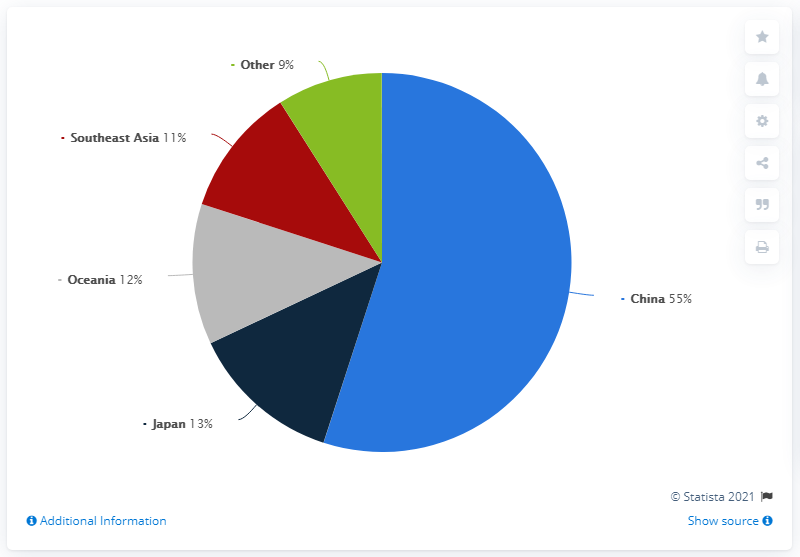Give some essential details in this illustration. In 2019, China accounted for 55% of Hugo Boss' total sales in the Asia Pacific region. The combined sales from countries other than China are less than that of China. The color of the dominant segment is blue. 